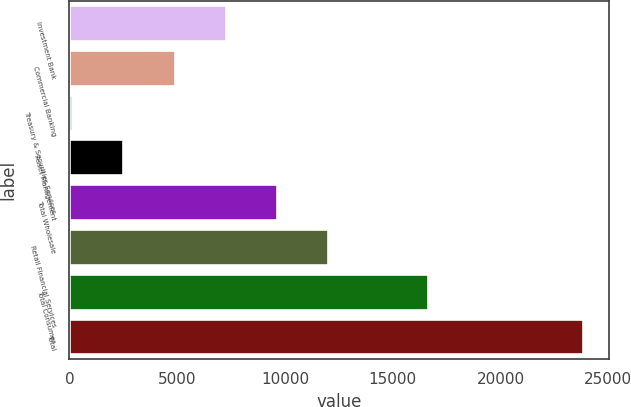<chart> <loc_0><loc_0><loc_500><loc_500><bar_chart><fcel>Investment Bank<fcel>Commercial Banking<fcel>Treasury & Securities Services<fcel>Asset Management<fcel>Total Wholesale<fcel>Retail Financial Services<fcel>Total Consumer<fcel>Total<nl><fcel>7242.8<fcel>4874.2<fcel>137<fcel>2505.6<fcel>9611.4<fcel>11980<fcel>16644<fcel>23823<nl></chart> 